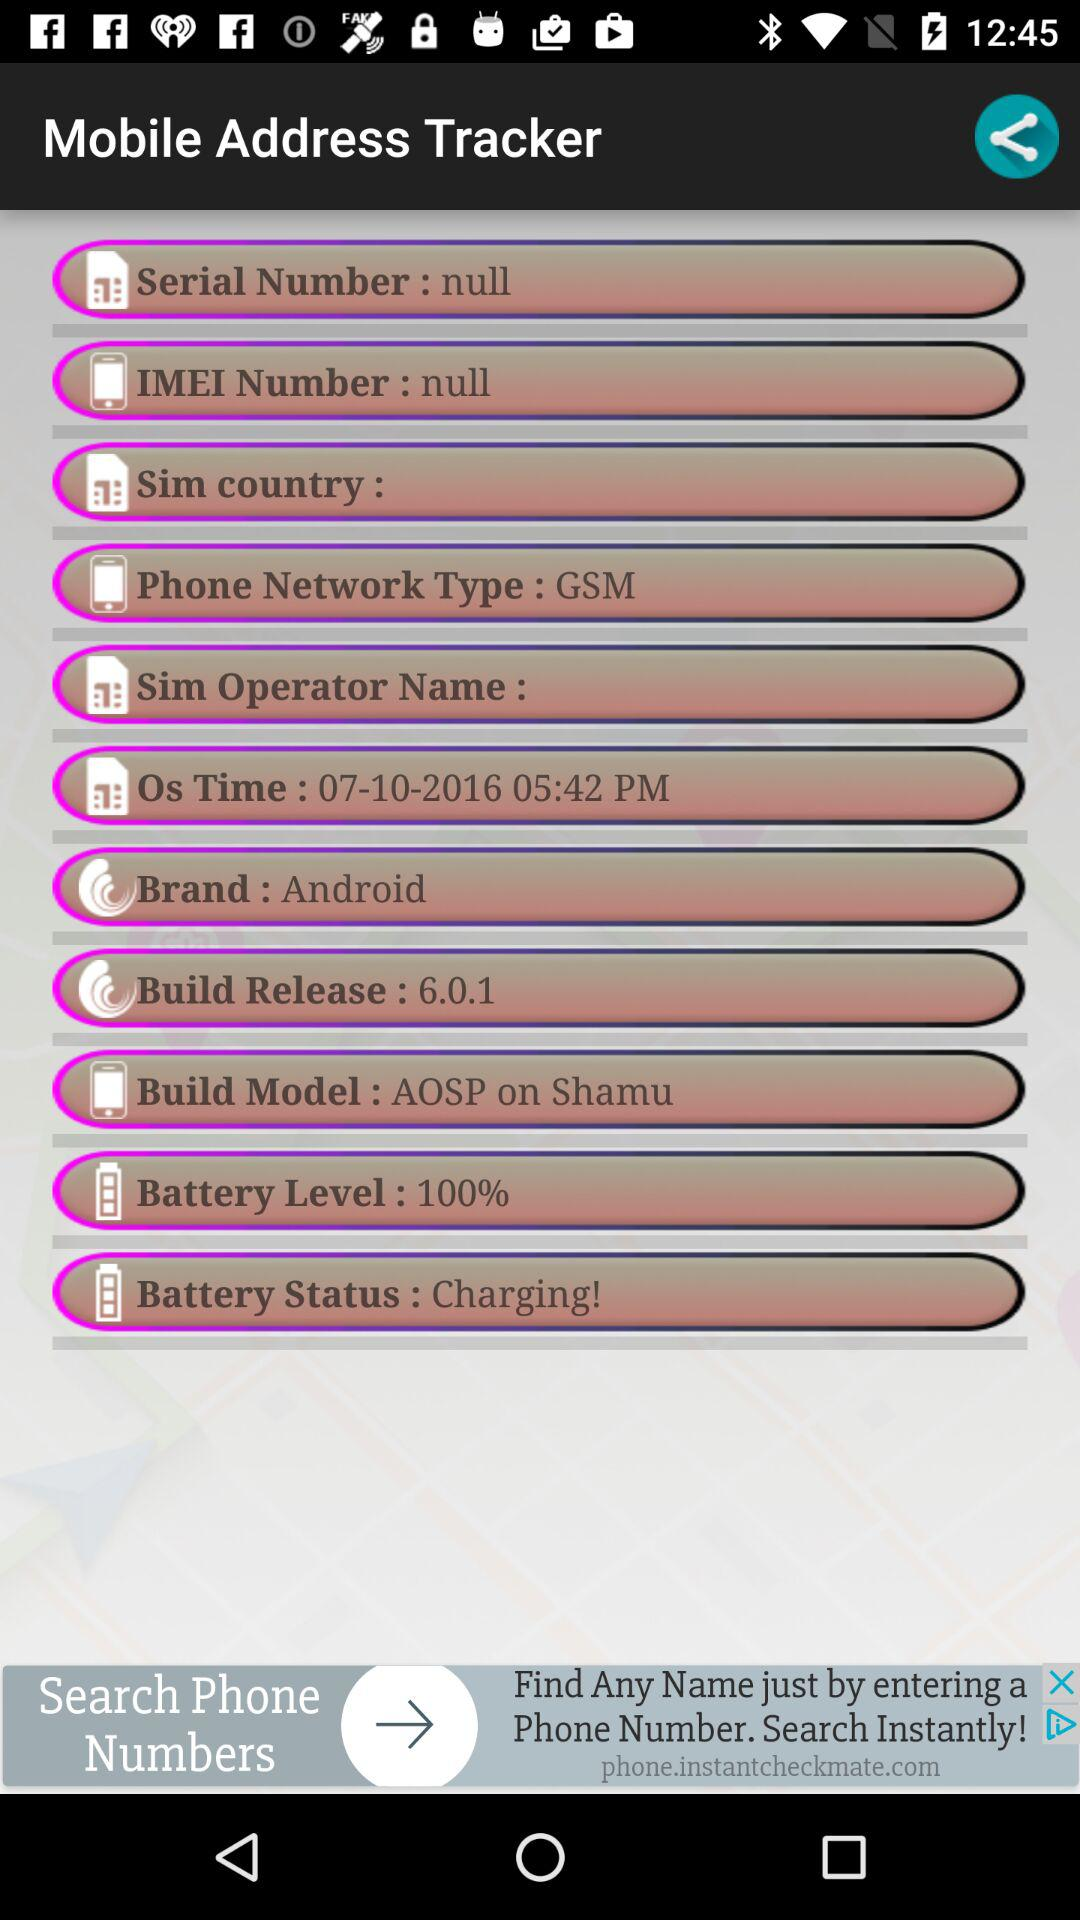What is the "Phone Network Type"? The "Phone Network Type" is "GSM". 